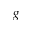<formula> <loc_0><loc_0><loc_500><loc_500>g</formula> 